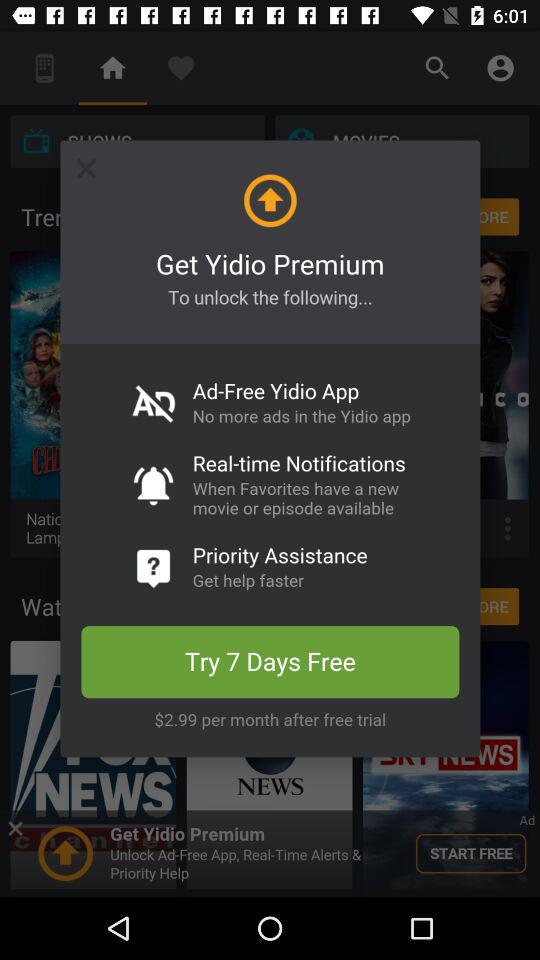How many more features do you get with the Premium subscription than the free subscription?
Answer the question using a single word or phrase. 3 